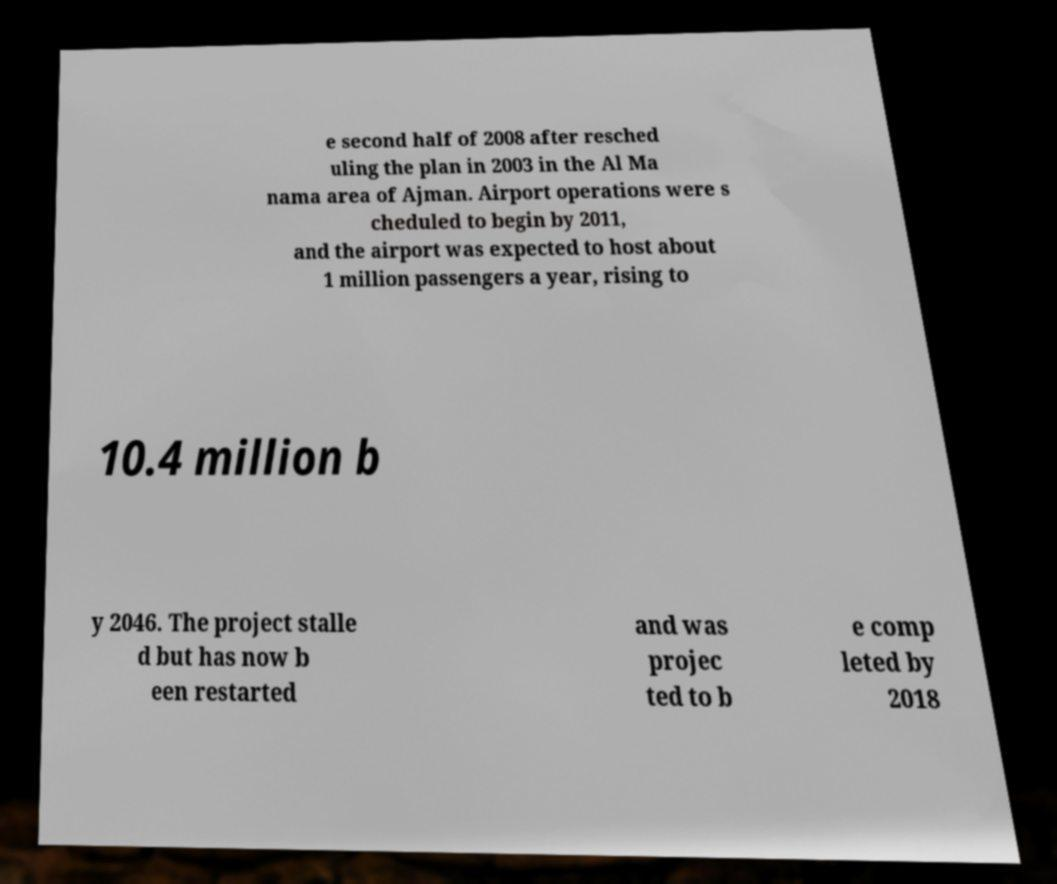Please read and relay the text visible in this image. What does it say? e second half of 2008 after resched uling the plan in 2003 in the Al Ma nama area of Ajman. Airport operations were s cheduled to begin by 2011, and the airport was expected to host about 1 million passengers a year, rising to 10.4 million b y 2046. The project stalle d but has now b een restarted and was projec ted to b e comp leted by 2018 